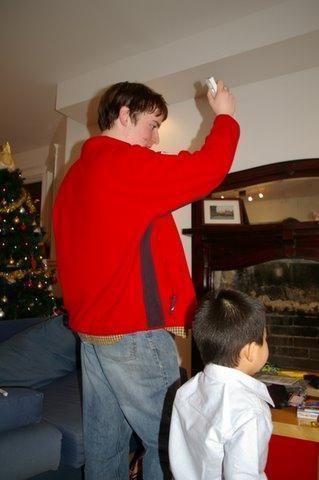How many people are in the picture?
Give a very brief answer. 2. How many people have and arm raised?
Give a very brief answer. 1. 